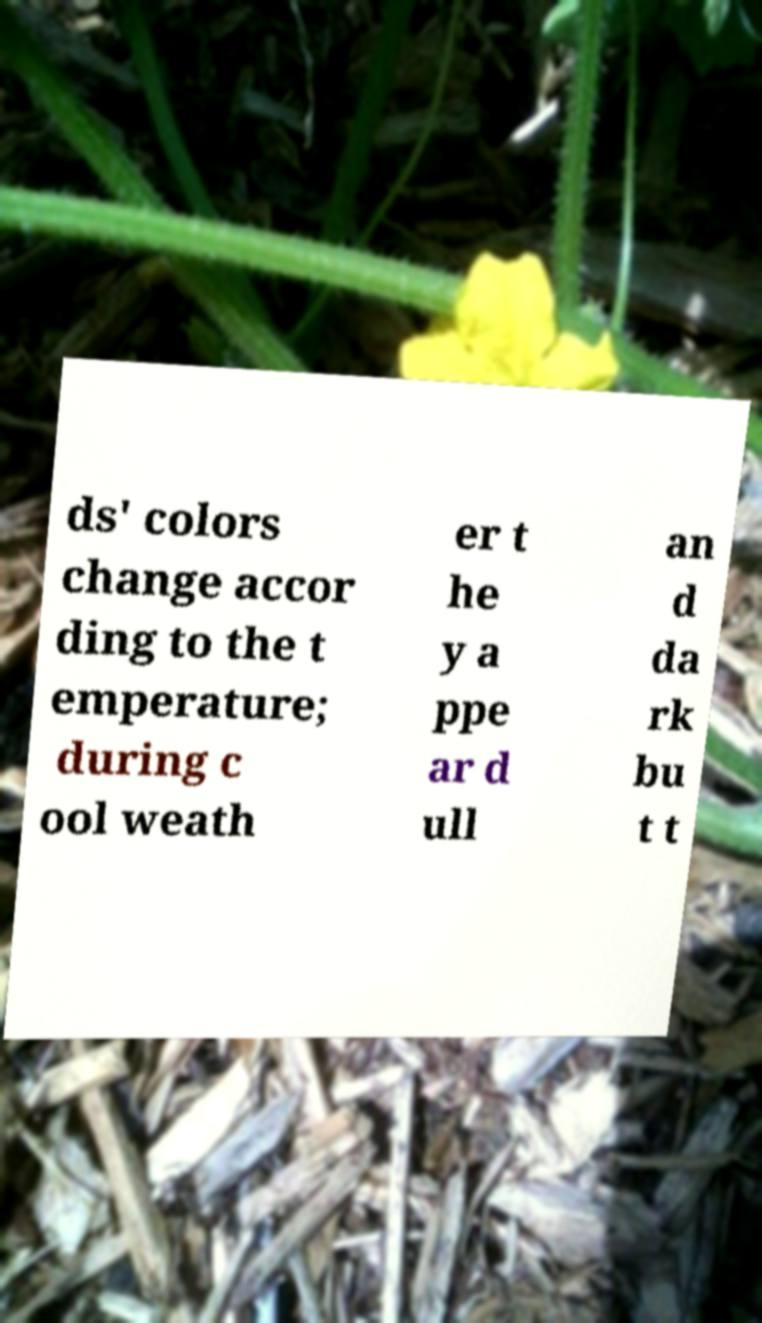I need the written content from this picture converted into text. Can you do that? ds' colors change accor ding to the t emperature; during c ool weath er t he y a ppe ar d ull an d da rk bu t t 